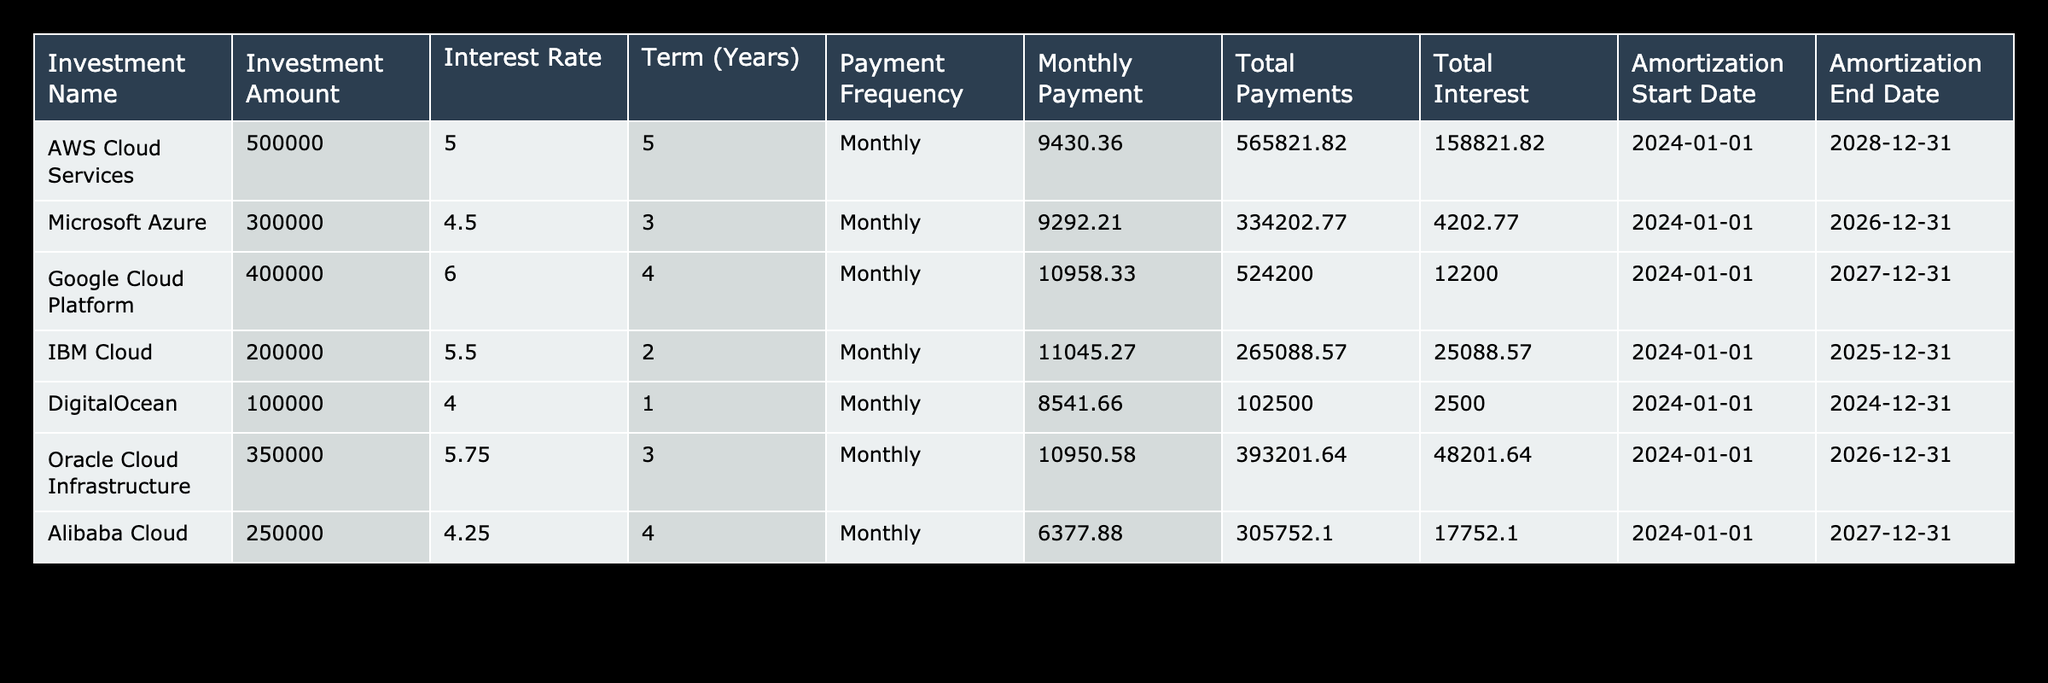What is the monthly payment for AWS Cloud Services? The table shows that for AWS Cloud Services, the Monthly Payment is listed as 9430.36.
Answer: 9430.36 Which investment has the highest total interest paid? By reviewing the Total Interest column, AWS Cloud Services has the highest Total Interest of 158821.82.
Answer: AWS Cloud Services How many total payments will be made for Google Cloud Platform? The Term for Google Cloud Platform is 4 years, and since payments are monthly, the Total Payments will be 4 years * 12 months/year = 48 payments.
Answer: 48 What is the average investment amount for all listed cloud services? The total investment amount is calculated as the sum of all amounts (500000 + 300000 + 400000 + 200000 + 100000 + 350000 + 250000) = 2100000. There are 7 investments, therefore the average is 2100000 / 7 = 300000.
Answer: 300000 Is the payment frequency for all investments monthly? Yes, all listed investments have a Payment Frequency of Monthly as shown in the table.
Answer: Yes Which investment has the shortest term and what is it? The investment with the shortest term is DigitalOcean, which has a Term of 1 year.
Answer: DigitalOcean If I sum the total payments for Oracle Cloud Infrastructure and Microsoft Azure, what is the resulting amount? The Total Payments for Oracle Cloud Infrastructure is 393201.64 and for Microsoft Azure it is 334202.77. Summing these gives 393201.64 + 334202.77 = 727404.41.
Answer: 727404.41 What is the difference in total interest between IBM Cloud and Alibaba Cloud? The total interest for IBM Cloud is 25088.57 and for Alibaba Cloud it is 17752.10. The difference is 25088.57 - 17752.10 = 7326.47.
Answer: 7326.47 Which two cloud services have a term greater than 3 years? AWS Cloud Services has a term of 5 years and Google Cloud Platform has a term of 4 years, both being greater than 3 years.
Answer: AWS Cloud Services, Google Cloud Platform 